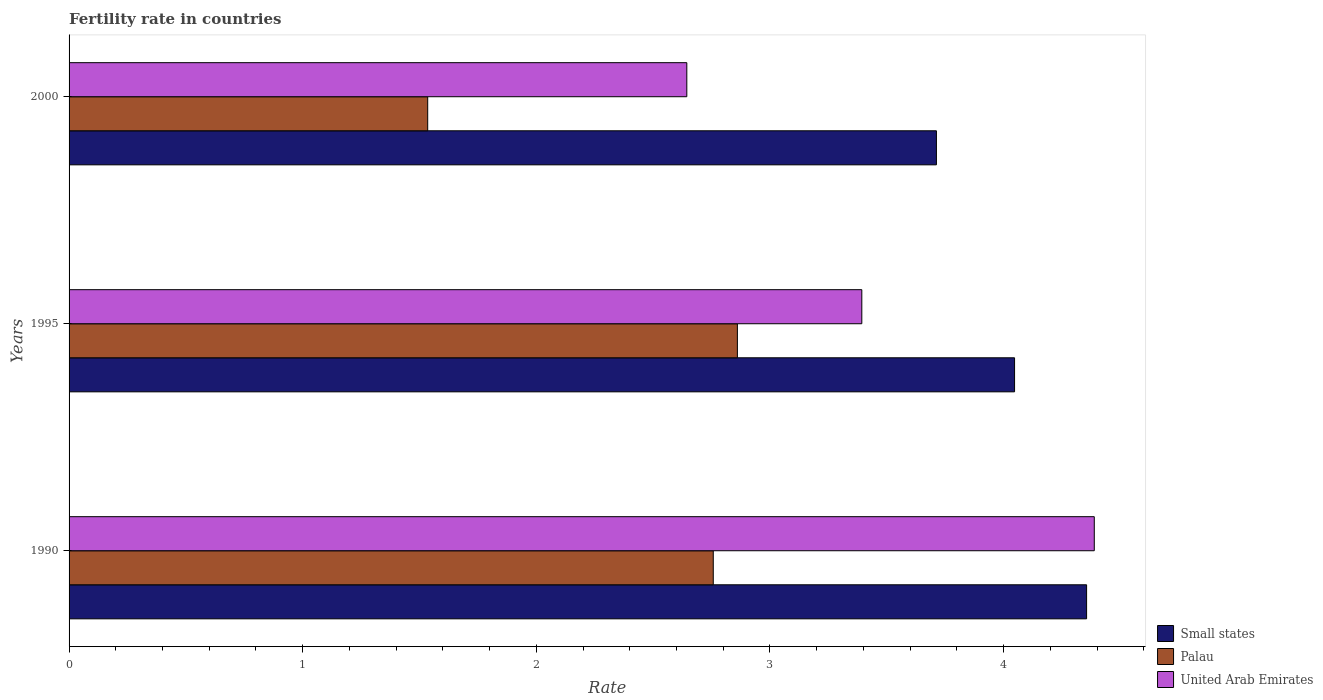How many different coloured bars are there?
Your answer should be compact. 3. Are the number of bars per tick equal to the number of legend labels?
Keep it short and to the point. Yes. How many bars are there on the 2nd tick from the top?
Offer a very short reply. 3. How many bars are there on the 2nd tick from the bottom?
Your answer should be very brief. 3. What is the fertility rate in Palau in 1990?
Provide a short and direct response. 2.76. Across all years, what is the maximum fertility rate in Palau?
Provide a short and direct response. 2.86. Across all years, what is the minimum fertility rate in Small states?
Your answer should be very brief. 3.71. In which year was the fertility rate in Palau maximum?
Your response must be concise. 1995. In which year was the fertility rate in Palau minimum?
Your answer should be very brief. 2000. What is the total fertility rate in Palau in the graph?
Your answer should be compact. 7.15. What is the difference between the fertility rate in United Arab Emirates in 1990 and that in 2000?
Your answer should be very brief. 1.74. What is the difference between the fertility rate in United Arab Emirates in 2000 and the fertility rate in Small states in 1995?
Your answer should be very brief. -1.4. What is the average fertility rate in Palau per year?
Provide a short and direct response. 2.38. In the year 1990, what is the difference between the fertility rate in Small states and fertility rate in Palau?
Provide a short and direct response. 1.6. What is the ratio of the fertility rate in United Arab Emirates in 1990 to that in 2000?
Your answer should be very brief. 1.66. Is the fertility rate in Palau in 1990 less than that in 1995?
Give a very brief answer. Yes. Is the difference between the fertility rate in Small states in 1995 and 2000 greater than the difference between the fertility rate in Palau in 1995 and 2000?
Provide a succinct answer. No. What is the difference between the highest and the second highest fertility rate in Palau?
Offer a very short reply. 0.1. What is the difference between the highest and the lowest fertility rate in United Arab Emirates?
Provide a succinct answer. 1.74. What does the 2nd bar from the top in 1990 represents?
Keep it short and to the point. Palau. What does the 3rd bar from the bottom in 1995 represents?
Ensure brevity in your answer.  United Arab Emirates. Are all the bars in the graph horizontal?
Your answer should be very brief. Yes. How are the legend labels stacked?
Offer a very short reply. Vertical. What is the title of the graph?
Keep it short and to the point. Fertility rate in countries. Does "Costa Rica" appear as one of the legend labels in the graph?
Give a very brief answer. No. What is the label or title of the X-axis?
Give a very brief answer. Rate. What is the Rate of Small states in 1990?
Give a very brief answer. 4.36. What is the Rate of Palau in 1990?
Your answer should be compact. 2.76. What is the Rate in United Arab Emirates in 1990?
Make the answer very short. 4.39. What is the Rate in Small states in 1995?
Your answer should be compact. 4.05. What is the Rate in Palau in 1995?
Your answer should be compact. 2.86. What is the Rate of United Arab Emirates in 1995?
Keep it short and to the point. 3.39. What is the Rate of Small states in 2000?
Offer a very short reply. 3.71. What is the Rate of Palau in 2000?
Ensure brevity in your answer.  1.53. What is the Rate of United Arab Emirates in 2000?
Provide a short and direct response. 2.64. Across all years, what is the maximum Rate in Small states?
Ensure brevity in your answer.  4.36. Across all years, what is the maximum Rate in Palau?
Give a very brief answer. 2.86. Across all years, what is the maximum Rate of United Arab Emirates?
Provide a short and direct response. 4.39. Across all years, what is the minimum Rate in Small states?
Your response must be concise. 3.71. Across all years, what is the minimum Rate of Palau?
Ensure brevity in your answer.  1.53. Across all years, what is the minimum Rate of United Arab Emirates?
Ensure brevity in your answer.  2.64. What is the total Rate of Small states in the graph?
Your answer should be compact. 12.11. What is the total Rate of Palau in the graph?
Your answer should be compact. 7.15. What is the total Rate in United Arab Emirates in the graph?
Ensure brevity in your answer.  10.43. What is the difference between the Rate of Small states in 1990 and that in 1995?
Offer a very short reply. 0.31. What is the difference between the Rate of Palau in 1990 and that in 1995?
Give a very brief answer. -0.1. What is the difference between the Rate in United Arab Emirates in 1990 and that in 1995?
Make the answer very short. 0.99. What is the difference between the Rate of Small states in 1990 and that in 2000?
Your response must be concise. 0.64. What is the difference between the Rate of Palau in 1990 and that in 2000?
Provide a short and direct response. 1.22. What is the difference between the Rate in United Arab Emirates in 1990 and that in 2000?
Your response must be concise. 1.74. What is the difference between the Rate in Small states in 1995 and that in 2000?
Your answer should be compact. 0.33. What is the difference between the Rate in Palau in 1995 and that in 2000?
Provide a succinct answer. 1.33. What is the difference between the Rate of United Arab Emirates in 1995 and that in 2000?
Provide a succinct answer. 0.75. What is the difference between the Rate in Small states in 1990 and the Rate in Palau in 1995?
Give a very brief answer. 1.49. What is the difference between the Rate in Small states in 1990 and the Rate in United Arab Emirates in 1995?
Provide a short and direct response. 0.96. What is the difference between the Rate in Palau in 1990 and the Rate in United Arab Emirates in 1995?
Offer a very short reply. -0.64. What is the difference between the Rate in Small states in 1990 and the Rate in Palau in 2000?
Your answer should be compact. 2.82. What is the difference between the Rate in Small states in 1990 and the Rate in United Arab Emirates in 2000?
Your response must be concise. 1.71. What is the difference between the Rate in Palau in 1990 and the Rate in United Arab Emirates in 2000?
Provide a succinct answer. 0.11. What is the difference between the Rate in Small states in 1995 and the Rate in Palau in 2000?
Provide a succinct answer. 2.51. What is the difference between the Rate in Small states in 1995 and the Rate in United Arab Emirates in 2000?
Offer a terse response. 1.4. What is the difference between the Rate of Palau in 1995 and the Rate of United Arab Emirates in 2000?
Provide a short and direct response. 0.22. What is the average Rate in Small states per year?
Provide a succinct answer. 4.04. What is the average Rate in Palau per year?
Your answer should be very brief. 2.38. What is the average Rate in United Arab Emirates per year?
Keep it short and to the point. 3.48. In the year 1990, what is the difference between the Rate in Small states and Rate in Palau?
Give a very brief answer. 1.6. In the year 1990, what is the difference between the Rate in Small states and Rate in United Arab Emirates?
Keep it short and to the point. -0.03. In the year 1990, what is the difference between the Rate of Palau and Rate of United Arab Emirates?
Your answer should be compact. -1.63. In the year 1995, what is the difference between the Rate of Small states and Rate of Palau?
Offer a very short reply. 1.19. In the year 1995, what is the difference between the Rate of Small states and Rate of United Arab Emirates?
Your response must be concise. 0.65. In the year 1995, what is the difference between the Rate of Palau and Rate of United Arab Emirates?
Your response must be concise. -0.53. In the year 2000, what is the difference between the Rate of Small states and Rate of Palau?
Ensure brevity in your answer.  2.18. In the year 2000, what is the difference between the Rate of Small states and Rate of United Arab Emirates?
Give a very brief answer. 1.07. In the year 2000, what is the difference between the Rate of Palau and Rate of United Arab Emirates?
Provide a succinct answer. -1.11. What is the ratio of the Rate of Small states in 1990 to that in 1995?
Ensure brevity in your answer.  1.08. What is the ratio of the Rate in Palau in 1990 to that in 1995?
Offer a very short reply. 0.96. What is the ratio of the Rate in United Arab Emirates in 1990 to that in 1995?
Provide a short and direct response. 1.29. What is the ratio of the Rate of Small states in 1990 to that in 2000?
Keep it short and to the point. 1.17. What is the ratio of the Rate in Palau in 1990 to that in 2000?
Your answer should be very brief. 1.8. What is the ratio of the Rate in United Arab Emirates in 1990 to that in 2000?
Your answer should be very brief. 1.66. What is the ratio of the Rate in Small states in 1995 to that in 2000?
Offer a very short reply. 1.09. What is the ratio of the Rate in Palau in 1995 to that in 2000?
Ensure brevity in your answer.  1.86. What is the ratio of the Rate in United Arab Emirates in 1995 to that in 2000?
Ensure brevity in your answer.  1.28. What is the difference between the highest and the second highest Rate in Small states?
Give a very brief answer. 0.31. What is the difference between the highest and the second highest Rate in Palau?
Offer a very short reply. 0.1. What is the difference between the highest and the second highest Rate of United Arab Emirates?
Your response must be concise. 0.99. What is the difference between the highest and the lowest Rate in Small states?
Make the answer very short. 0.64. What is the difference between the highest and the lowest Rate of Palau?
Offer a terse response. 1.33. What is the difference between the highest and the lowest Rate in United Arab Emirates?
Offer a very short reply. 1.74. 